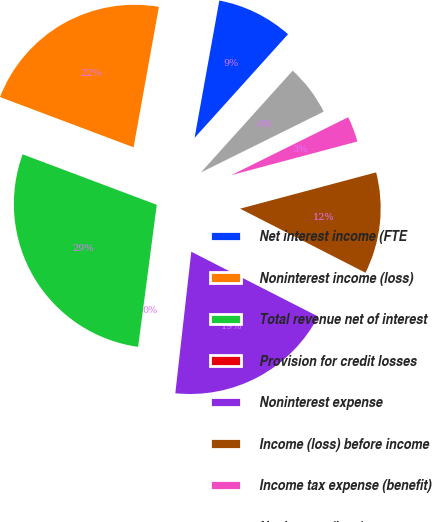Convert chart to OTSL. <chart><loc_0><loc_0><loc_500><loc_500><pie_chart><fcel>Net interest income (FTE<fcel>Noninterest income (loss)<fcel>Total revenue net of interest<fcel>Provision for credit losses<fcel>Noninterest expense<fcel>Income (loss) before income<fcel>Income tax expense (benefit)<fcel>Net income (loss)<nl><fcel>8.84%<fcel>22.11%<fcel>28.65%<fcel>0.29%<fcel>19.27%<fcel>11.67%<fcel>3.17%<fcel>6.0%<nl></chart> 